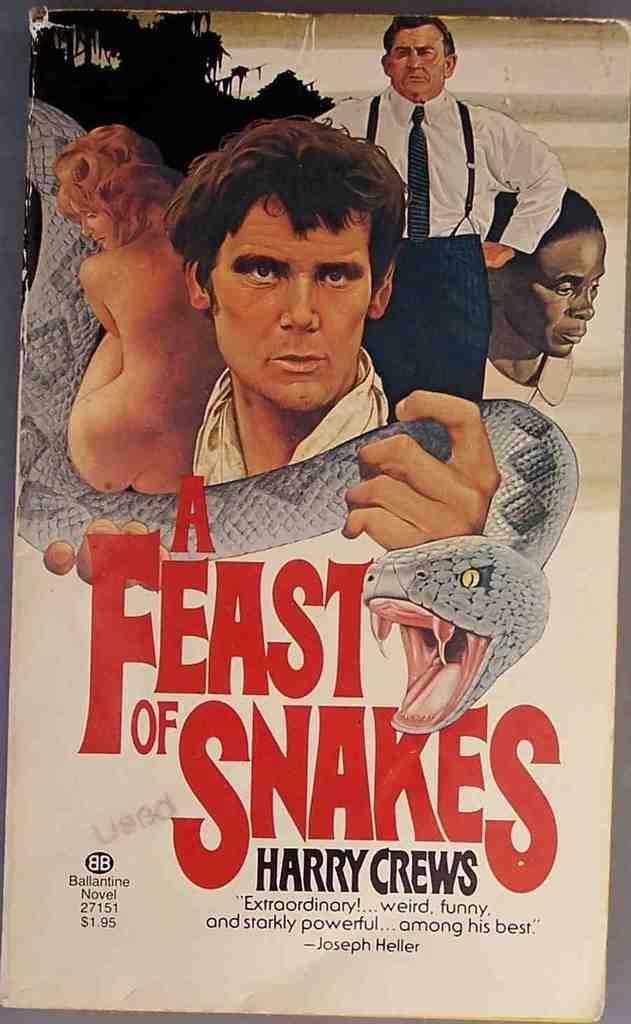<image>
Relay a brief, clear account of the picture shown. Book cover for A Feast of Snakes showing a man holding a giant snake. 